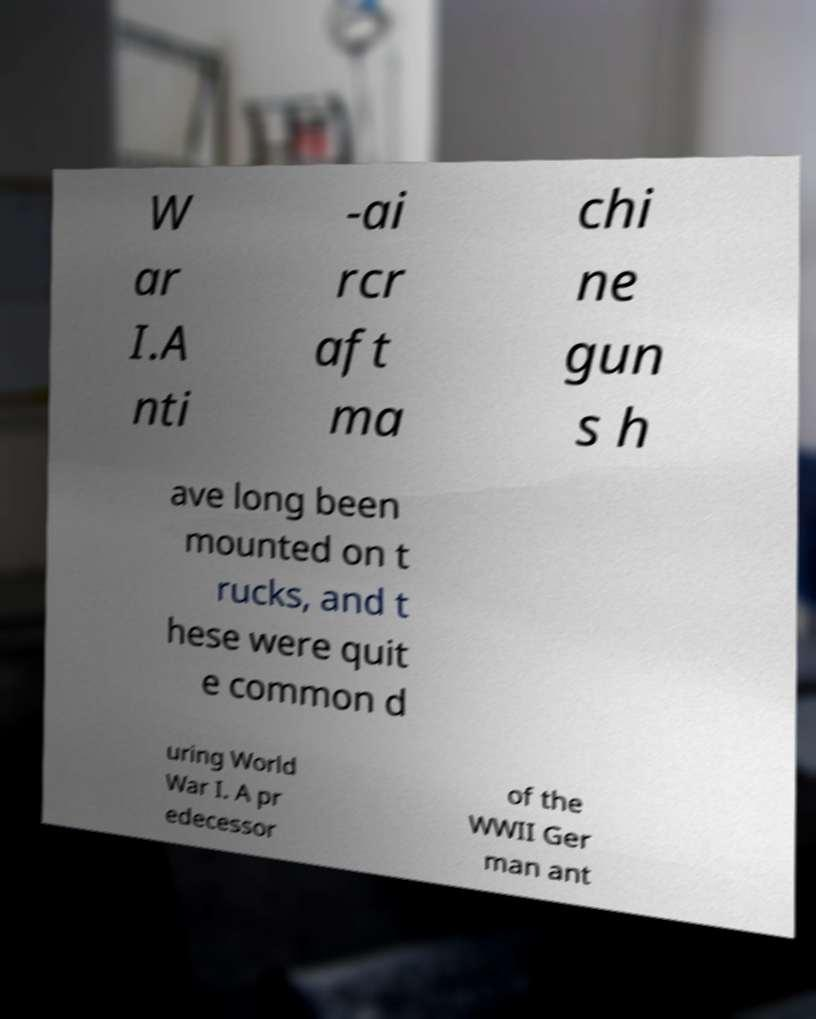For documentation purposes, I need the text within this image transcribed. Could you provide that? W ar I.A nti -ai rcr aft ma chi ne gun s h ave long been mounted on t rucks, and t hese were quit e common d uring World War I. A pr edecessor of the WWII Ger man ant 